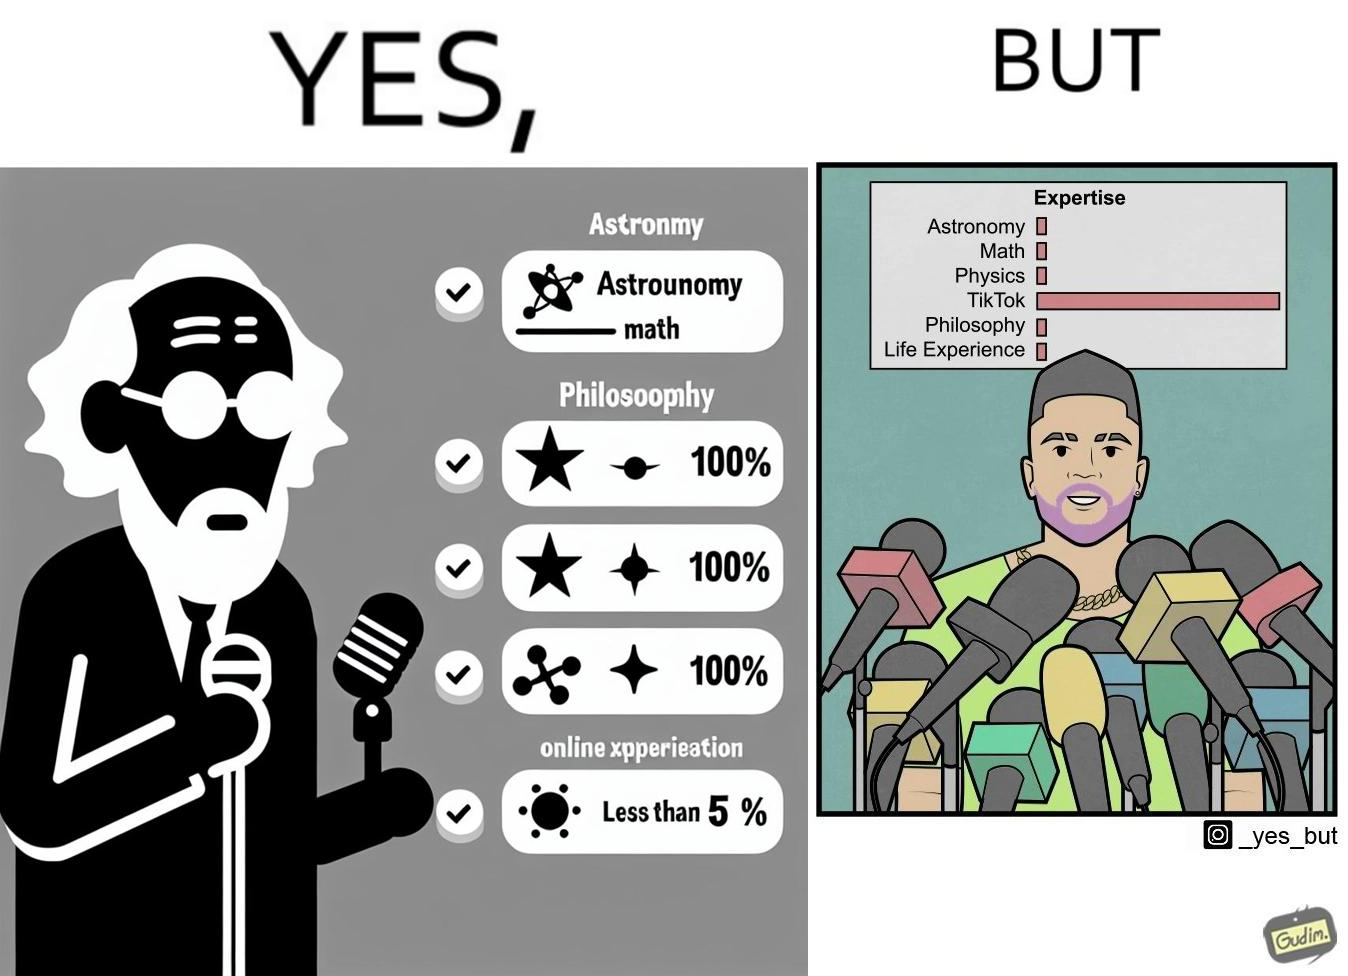Is this image satirical or non-satirical? Yes, this image is satirical. 